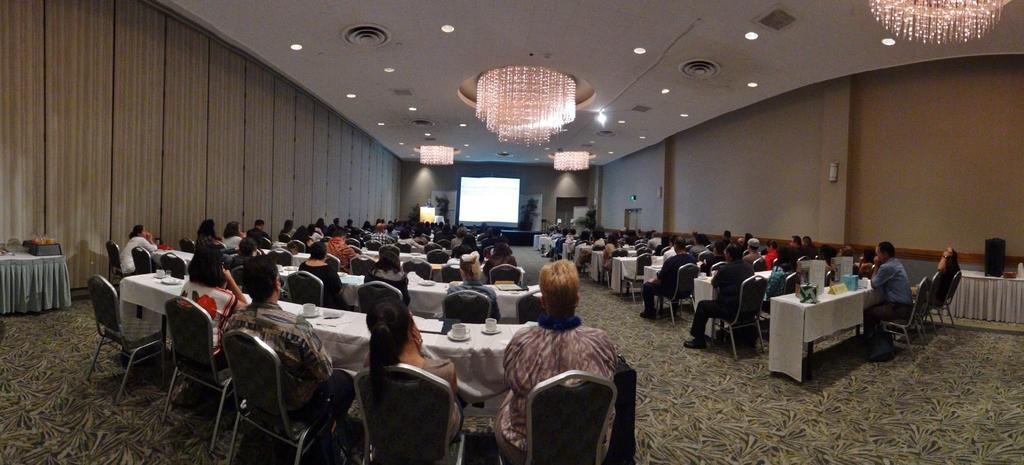Can you describe this image briefly? In the image in the center, we can see a few people are sitting on the chair. In front of them, we can see tables. On the tables, we can see boxes, cups, saucers and a few other objects. In the background there is a wall, roof, screen and lights. 